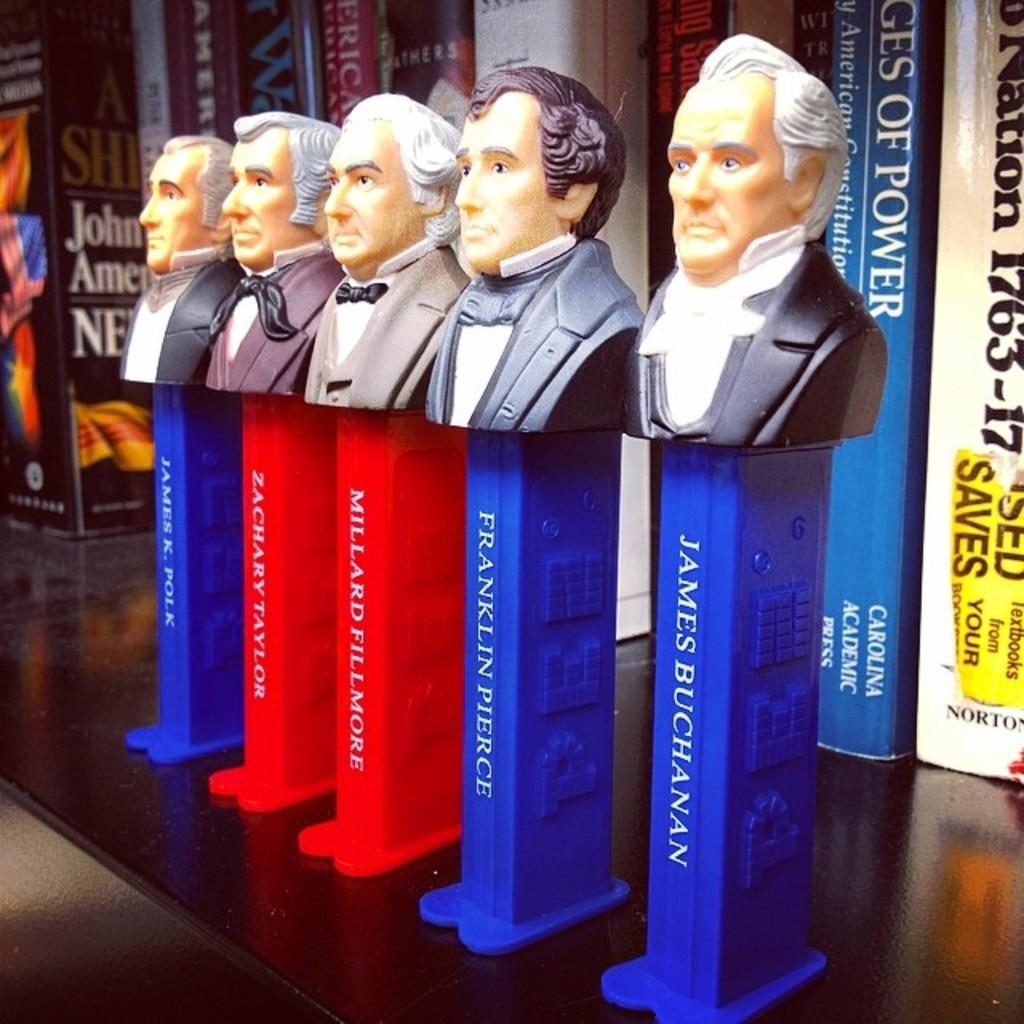Which former president's likeness is sitting on the far right?
Keep it short and to the point. James buchanan. 